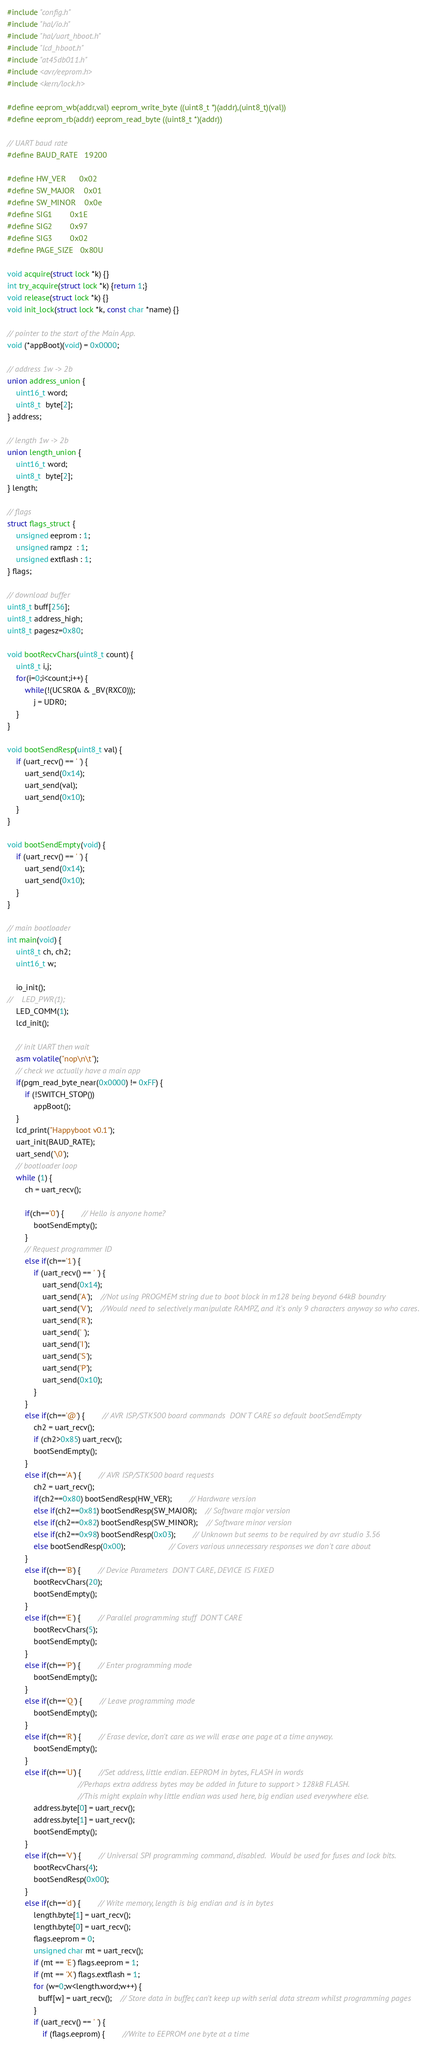Convert code to text. <code><loc_0><loc_0><loc_500><loc_500><_C_>#include "config.h"
#include "hal/io.h"
#include "hal/uart_hboot.h"
#include "lcd_hboot.h"
#include "at45db011.h"
#include <avr/eeprom.h>
#include <kern/lock.h>

#define eeprom_wb(addr,val) eeprom_write_byte ((uint8_t *)(addr),(uint8_t)(val))
#define eeprom_rb(addr) eeprom_read_byte ((uint8_t *)(addr))

// UART baud rate
#define BAUD_RATE   19200

#define HW_VER      0x02
#define SW_MAJOR    0x01
#define SW_MINOR    0x0e
#define SIG1        0x1E
#define SIG2        0x97
#define SIG3        0x02
#define PAGE_SIZE   0x80U

void acquire(struct lock *k) {}
int try_acquire(struct lock *k) {return 1;}
void release(struct lock *k) {}
void init_lock(struct lock *k, const char *name) {}

// pointer to the start of the Main App.
void (*appBoot)(void) = 0x0000;

// address 1w -> 2b
union address_union {
    uint16_t word;
    uint8_t  byte[2];
} address;

// length 1w -> 2b
union length_union {
    uint16_t word;
    uint8_t  byte[2];
} length;

// flags
struct flags_struct {
    unsigned eeprom : 1;
    unsigned rampz  : 1;
    unsigned extflash : 1;
} flags;

// download buffer
uint8_t buff[256];
uint8_t address_high;
uint8_t pagesz=0x80;

void bootRecvChars(uint8_t count) {
    uint8_t i,j;
    for(i=0;i<count;i++) {
        while(!(UCSR0A & _BV(RXC0)));
            j = UDR0;
    }
}

void bootSendResp(uint8_t val) {
    if (uart_recv() == ' ') {
        uart_send(0x14);
        uart_send(val);
        uart_send(0x10);
    }
}

void bootSendEmpty(void) {
    if (uart_recv() == ' ') {
        uart_send(0x14);
        uart_send(0x10);
    }
}

// main bootloader
int main(void) {
    uint8_t ch, ch2;
    uint16_t w;

    io_init();
//    LED_PWR(1);
    LED_COMM(1);
    lcd_init();

    // init UART then wait
    asm volatile("nop\n\t");
    // check we actually have a main app
    if(pgm_read_byte_near(0x0000) != 0xFF) {
        if (!SWITCH_STOP())
            appBoot();
    }
    lcd_print("Happyboot v0.1");
    uart_init(BAUD_RATE);
    uart_send('\0');
    // bootloader loop
    while (1) {
        ch = uart_recv();

        if(ch=='0') {        // Hello is anyone home?
            bootSendEmpty();
        }
        // Request programmer ID
        else if(ch=='1') {
            if (uart_recv() == ' ') {
                uart_send(0x14);
                uart_send('A');    //Not using PROGMEM string due to boot block in m128 being beyond 64kB boundry
                uart_send('V');    //Would need to selectively manipulate RAMPZ, and it's only 9 characters anyway so who cares.
                uart_send('R');
                uart_send(' ');
                uart_send('I');
                uart_send('S');
                uart_send('P');
                uart_send(0x10);
            }
        }
        else if(ch=='@') {        // AVR ISP/STK500 board commands  DON'T CARE so default bootSendEmpty
            ch2 = uart_recv();
            if (ch2>0x85) uart_recv();
            bootSendEmpty();
        }
        else if(ch=='A') {        // AVR ISP/STK500 board requests
            ch2 = uart_recv();
            if(ch2==0x80) bootSendResp(HW_VER);        // Hardware version
            else if(ch2==0x81) bootSendResp(SW_MAJOR);    // Software major version
            else if(ch2==0x82) bootSendResp(SW_MINOR);    // Software minor version
            else if(ch2==0x98) bootSendResp(0x03);        // Unknown but seems to be required by avr studio 3.56
            else bootSendResp(0x00);                    // Covers various unnecessary responses we don't care about
        }
        else if(ch=='B') {        // Device Parameters  DON'T CARE, DEVICE IS FIXED
            bootRecvChars(20);
            bootSendEmpty();
        }
        else if(ch=='E') {        // Parallel programming stuff  DON'T CARE
            bootRecvChars(5);
            bootSendEmpty();
        }
        else if(ch=='P') {        // Enter programming mode
            bootSendEmpty();
        }
        else if(ch=='Q') {        // Leave programming mode
            bootSendEmpty();
        }
        else if(ch=='R') {        // Erase device, don't care as we will erase one page at a time anyway.
            bootSendEmpty();
        }
        else if(ch=='U') {        //Set address, little endian. EEPROM in bytes, FLASH in words
                                //Perhaps extra address bytes may be added in future to support > 128kB FLASH.
                                //This might explain why little endian was used here, big endian used everywhere else.
            address.byte[0] = uart_recv();
            address.byte[1] = uart_recv();
            bootSendEmpty();
        }
        else if(ch=='V') {        // Universal SPI programming command, disabled.  Would be used for fuses and lock bits.
            bootRecvChars(4);
            bootSendResp(0x00);
        }
        else if(ch=='d') {        // Write memory, length is big endian and is in bytes
            length.byte[1] = uart_recv();
            length.byte[0] = uart_recv();
            flags.eeprom = 0;
            unsigned char mt = uart_recv();
            if (mt == 'E') flags.eeprom = 1;
            if (mt == 'X') flags.extflash = 1;
            for (w=0;w<length.word;w++) {
              buff[w] = uart_recv();    // Store data in buffer, can't keep up with serial data stream whilst programming pages
            }
            if (uart_recv() == ' ') {
                if (flags.eeprom) {        //Write to EEPROM one byte at a time</code> 